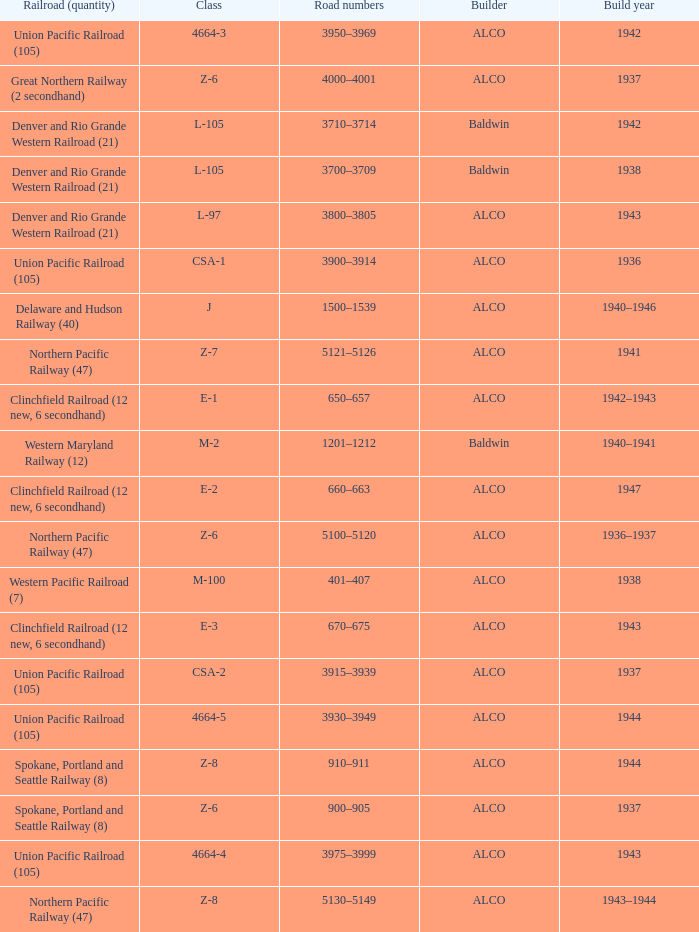What is the road numbers when the class is z-7? 5121–5126. 